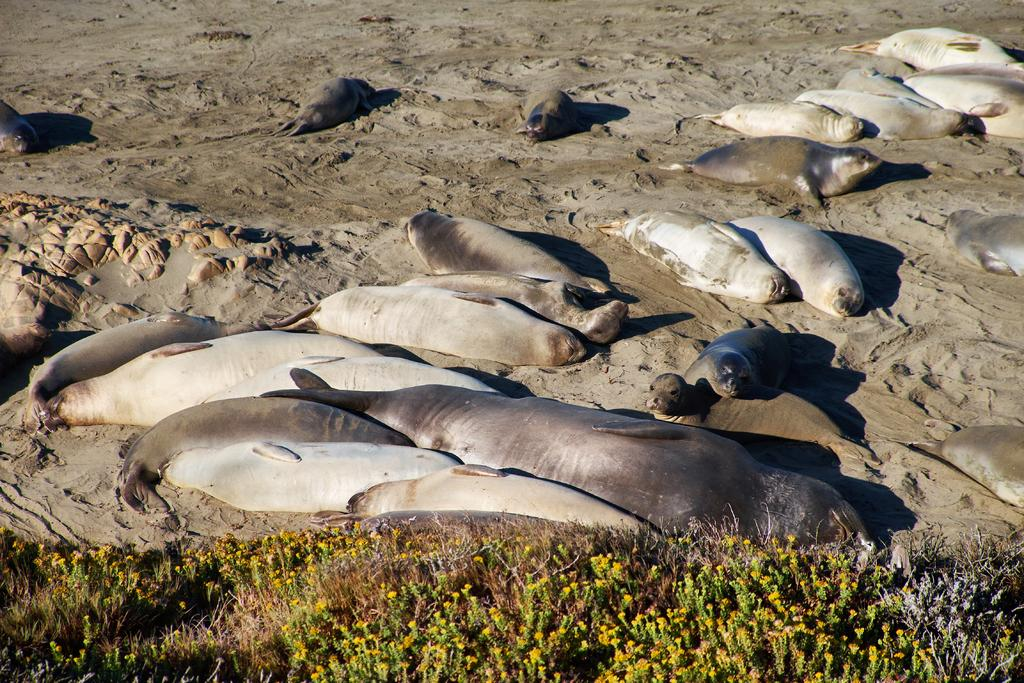What animals can be seen in the image? There are seals in the image. Where are the seals located? The seals are on the ground in the image. What type of terrain is visible in the image? There is sand in the image. What type of vegetation is present in the foreground of the image? There are plants and flowers in the foreground of the image. What type of wire is being used by the laborer in the image? There is no laborer or wire present in the image; it features seals on the ground with sand, plants, and flowers in the foreground. 